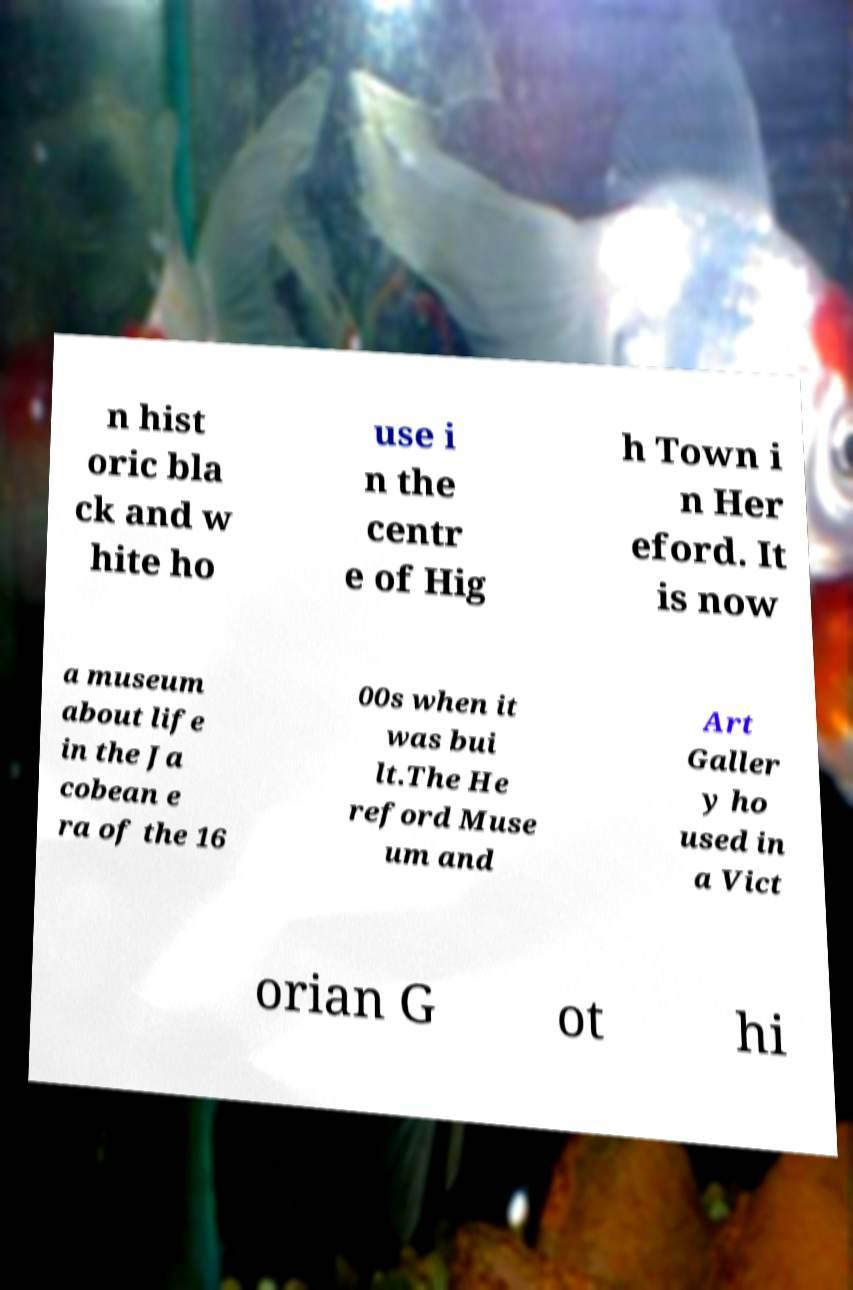I need the written content from this picture converted into text. Can you do that? n hist oric bla ck and w hite ho use i n the centr e of Hig h Town i n Her eford. It is now a museum about life in the Ja cobean e ra of the 16 00s when it was bui lt.The He reford Muse um and Art Galler y ho used in a Vict orian G ot hi 